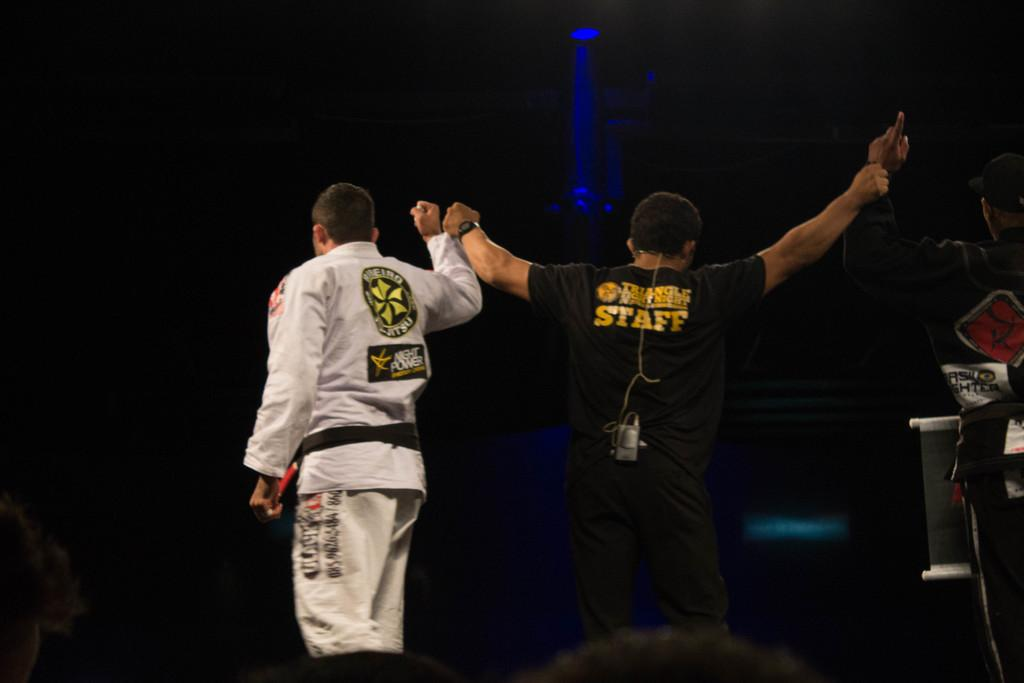<image>
Create a compact narrative representing the image presented. a couple of people with one wearing a staff shirt 